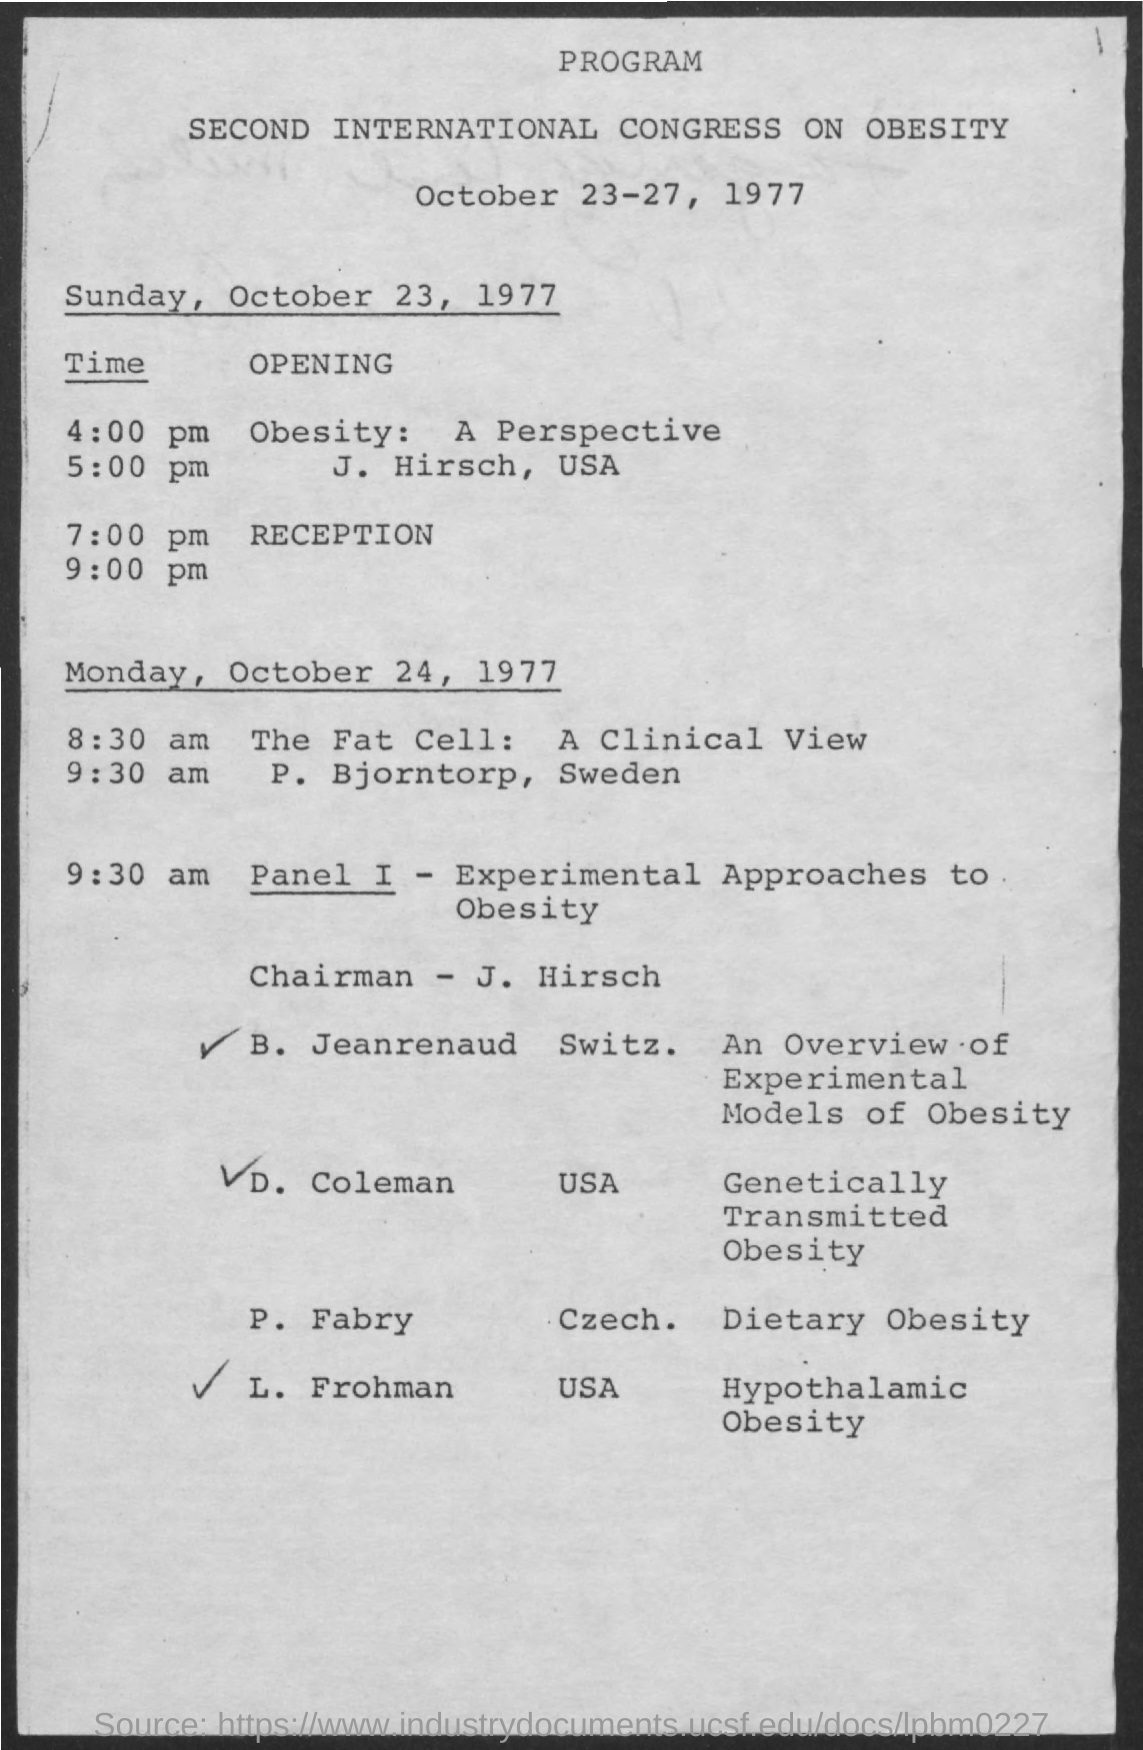who is the chairman ? The chairman for the panel at the Second International Congress on Obesity in 1977 is J. Hirsch from the USA, who also contributed to a perspective session on obesity. 